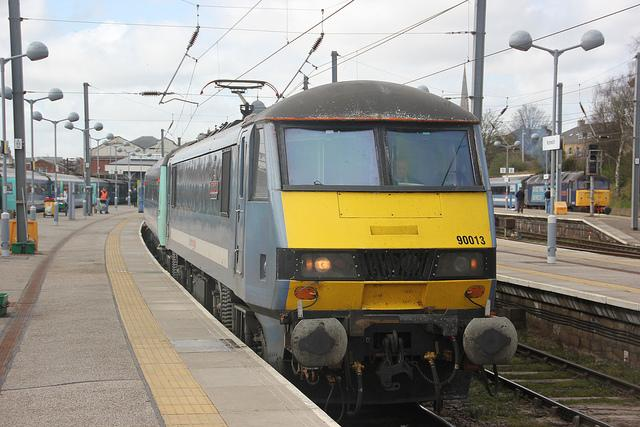For what group of people is the yellow area on the platform built? Please explain your reasoning. blind people. The yellow area helps ensure that these people stay back a sufficient distance to be safe. 